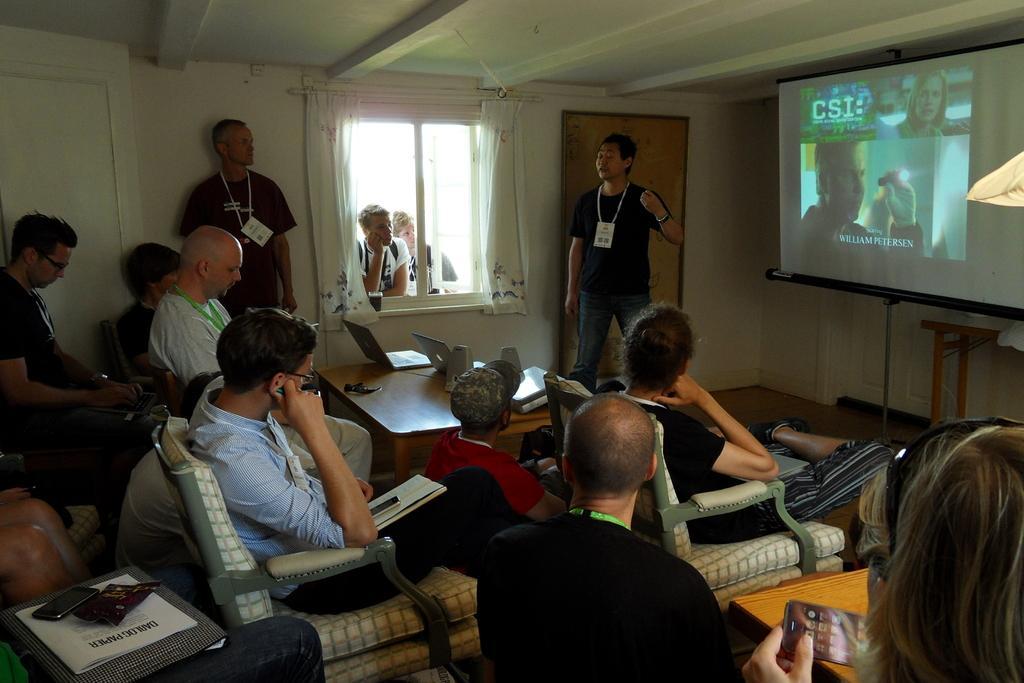Please provide a concise description of this image. In this picture we can see some people are sitting on chairs, books and mobiles. In front of them we can see some people are standing, screen, walls, window with curtains, some objects, table with laptops and speakers on it. 